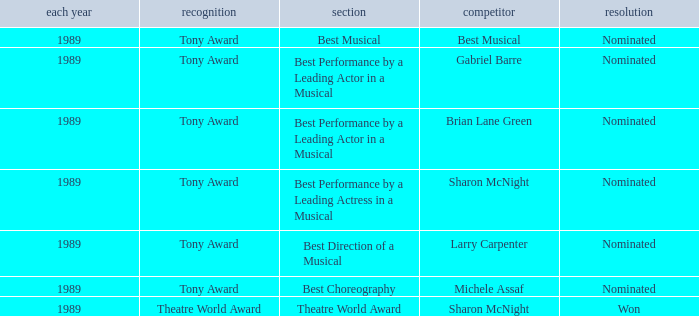What was the nominee of best musical Best Musical. 